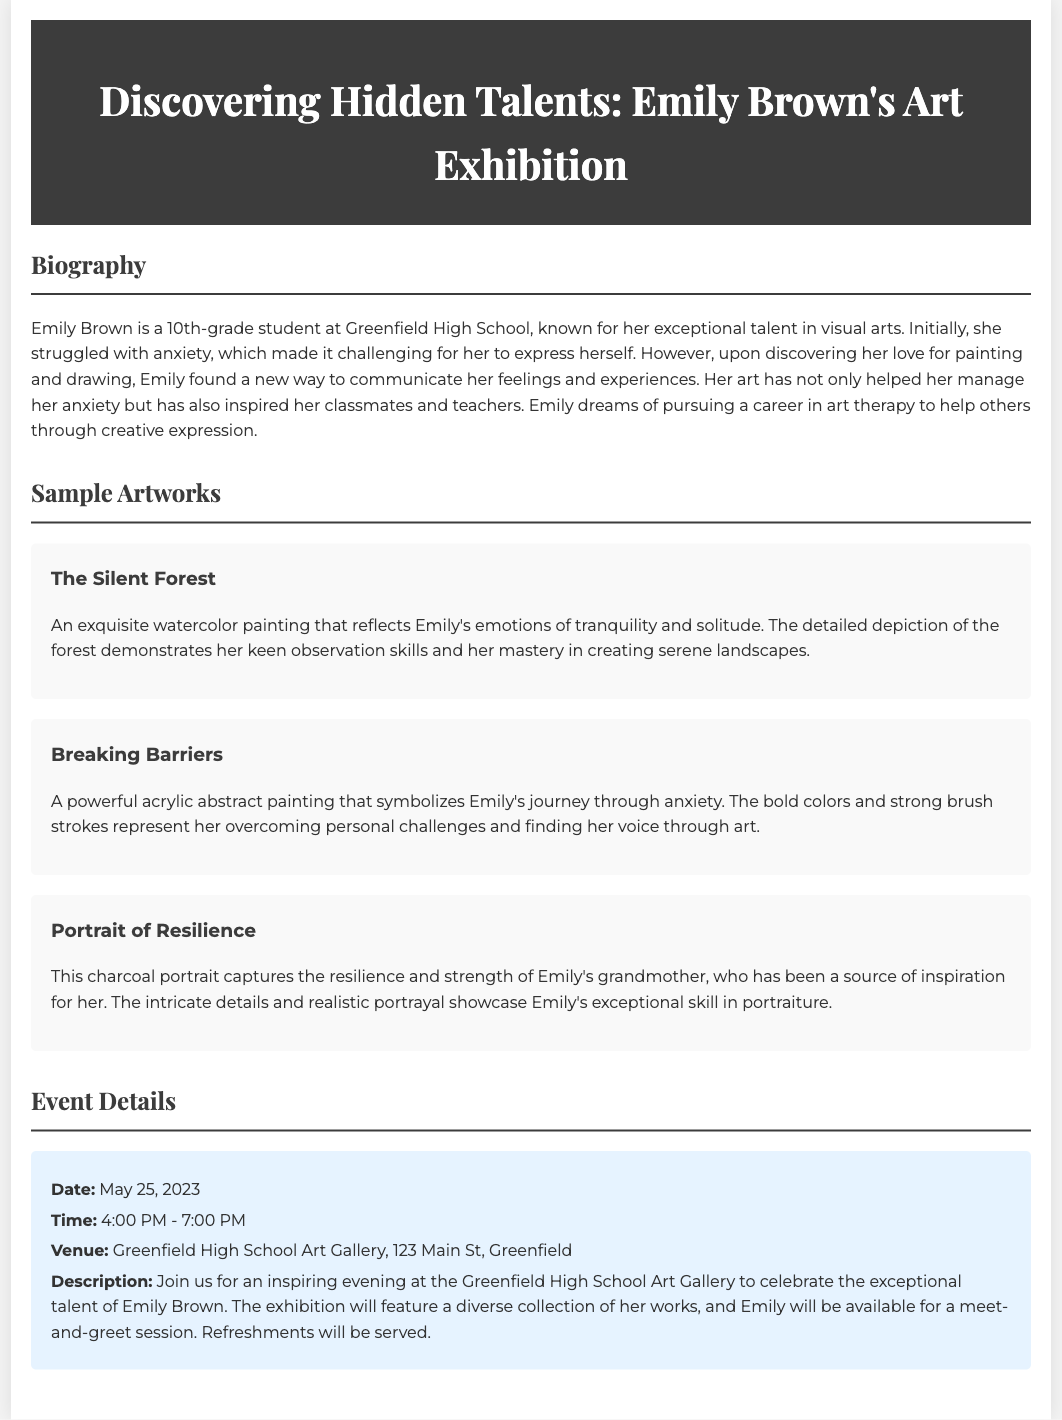What is the name of the artist? The document introduces the artist as Emily Brown, who is a 10th-grade student known for her exceptional talent in visual arts.
Answer: Emily Brown What is the date of the exhibition? According to the event details section, the exhibition is scheduled for May 25, 2023.
Answer: May 25, 2023 What type of painting is "The Silent Forest"? The description for "The Silent Forest" indicates that it is an exquisite watercolor painting.
Answer: Watercolor What career does Emily aspire to pursue? The biography section mentions that Emily dreams of pursuing a career in art therapy to help others through creative expression.
Answer: Art therapy What time does the event start? The event details specify that the exhibition starts at 4:00 PM.
Answer: 4:00 PM What artwork symbolizes Emily's journey through anxiety? The description for the artwork "Breaking Barriers" states that it symbolizes Emily's journey through anxiety.
Answer: Breaking Barriers Where is the venue for the art exhibition? The event details section states that the exhibition will be held at Greenfield High School Art Gallery, 123 Main St, Greenfield.
Answer: Greenfield High School Art Gallery What medium is used in the artwork "Portrait of Resilience"? The description for "Portrait of Resilience" specifies that it is a charcoal portrait.
Answer: Charcoal 